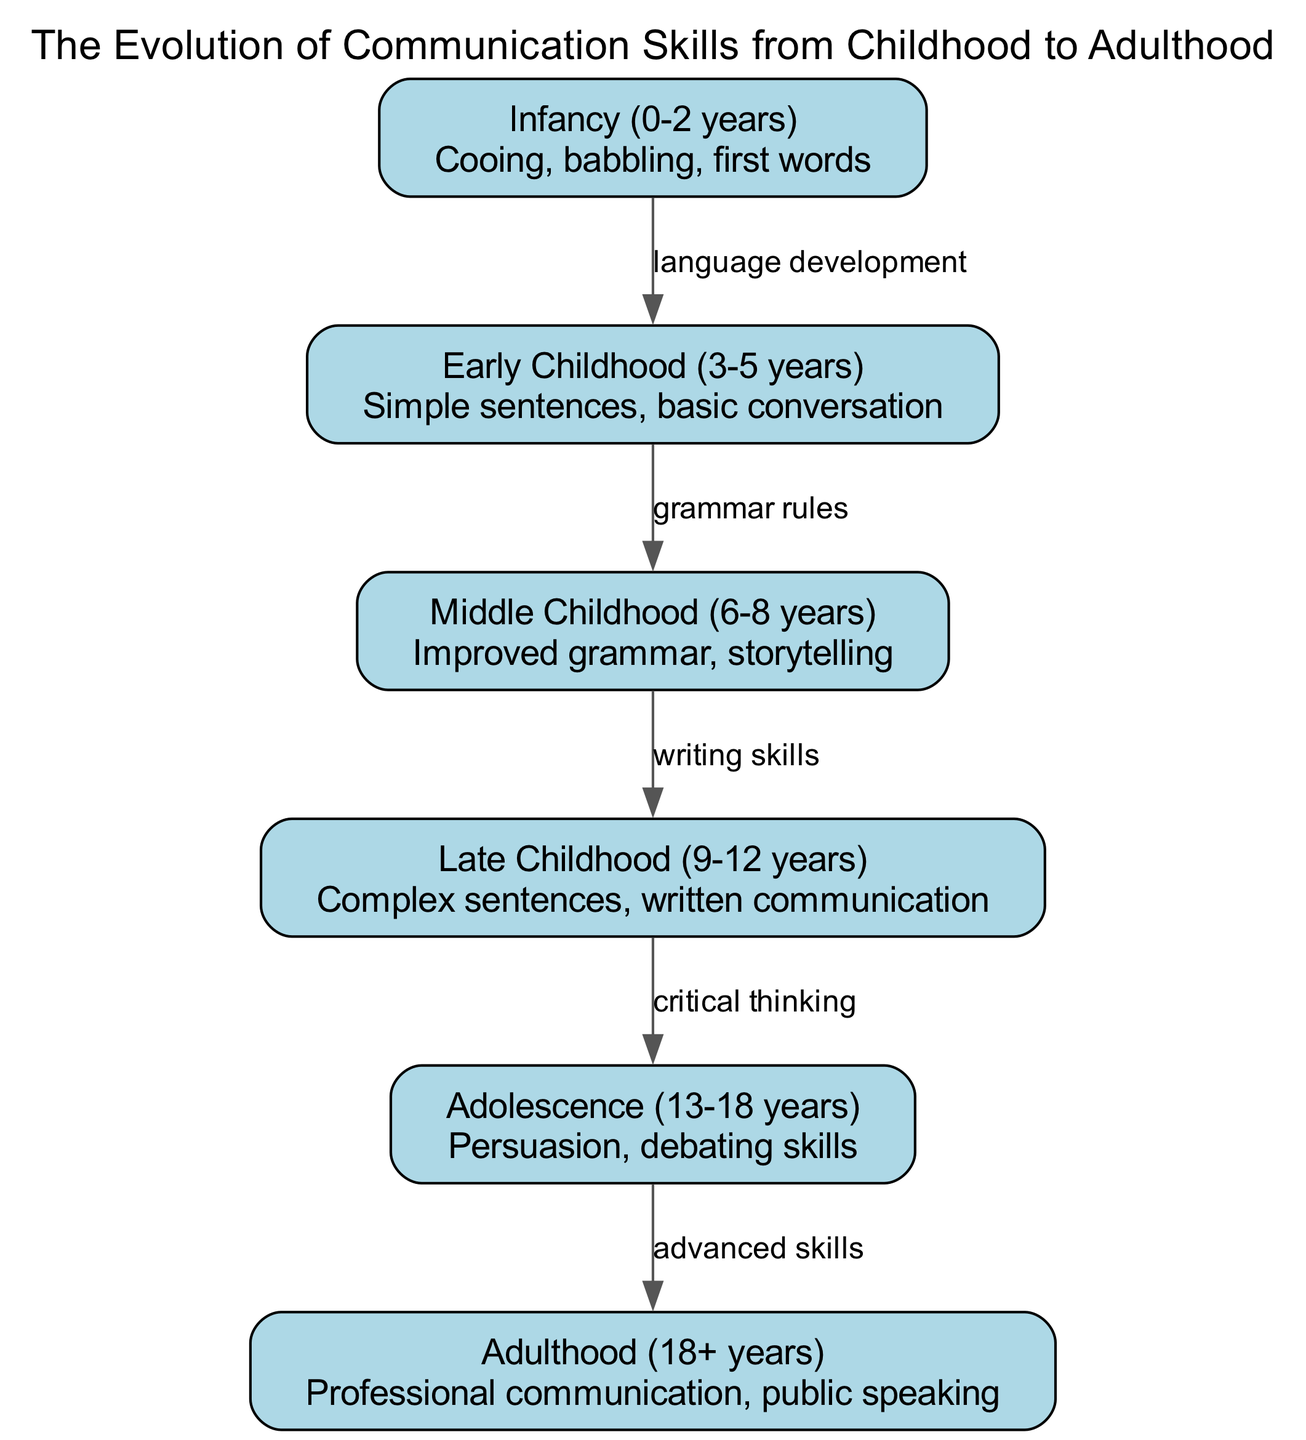What is the first milestone in communication skills development? The diagram indicates that the first milestone is "Cooing, babbling, first words" which is part of the "Infancy (0-2 years)" node.
Answer: Cooing, babbling, first words How many nodes are present in the diagram? By counting the individual nodes listed, there are six unique stages of communication development from infancy to adulthood, so the total is six.
Answer: 6 What relationship exists between Early Childhood and Middle Childhood? The edge connecting these two nodes is labeled "grammar rules," which indicates that grammar skills improve from Early Childhood to Middle Childhood.
Answer: grammar rules During which stage do individuals develop persuasion skills? The description under "Adolescence (13-18 years)" states that this is when persuasion and debating skills emerge and develop significantly.
Answer: Adolescence What is the primary focus of communication skills in Late Childhood? The "Late Childhood (9-12 years)" node highlights "Complex sentences, written communication" as the main focus for this stage.
Answer: Complex sentences, written communication Which edge connects Late Childhood to Adolescence? The diagram shows that the relationship between these two stages is defined by "critical thinking," illustrating the importance of developing critical thinking as a transition to adolescence.
Answer: critical thinking What is the last milestone in communication skills before adulthood? The milestone just before adulthood is marked as "Persuasion, debating skills" in the Adolescence stage, indicating the last developmental focus before entering adulthood.
Answer: Persuasion, debating skills What type of communication skills are emphasized in Adulthood? According to the description for "Adulthood (18+ years)," the focus is on "Professional communication, public speaking," underscoring the advanced communication abilities expected at this stage.
Answer: Professional communication, public speaking Which stage involves improved grammar and storytelling? The "Middle Childhood (6-8 years)" node specifies that this stage emphasizes improved grammar and the ability to tell stories, correlating it to the development milestones in language.
Answer: Improved grammar, storytelling 